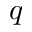<formula> <loc_0><loc_0><loc_500><loc_500>q</formula> 